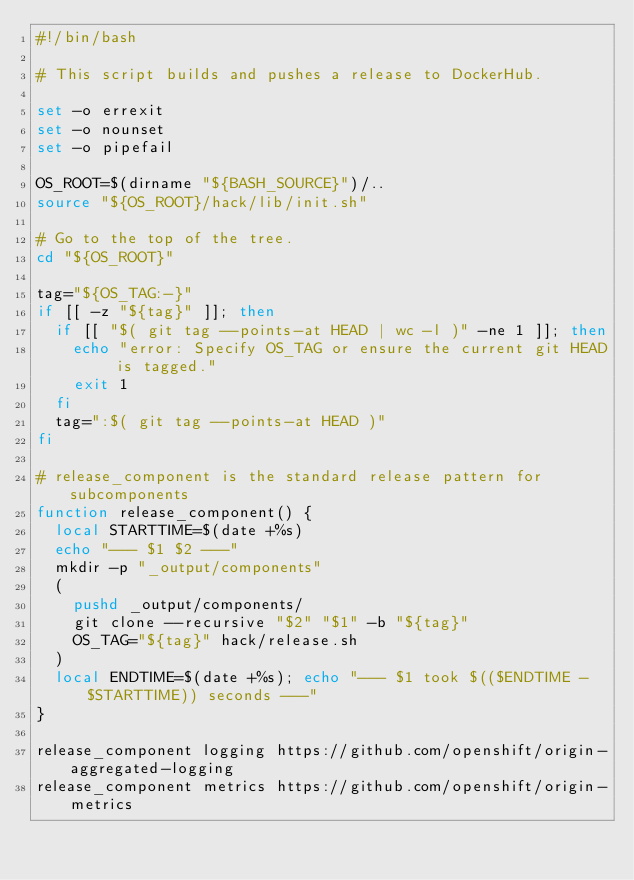<code> <loc_0><loc_0><loc_500><loc_500><_Bash_>#!/bin/bash

# This script builds and pushes a release to DockerHub.

set -o errexit
set -o nounset
set -o pipefail

OS_ROOT=$(dirname "${BASH_SOURCE}")/..
source "${OS_ROOT}/hack/lib/init.sh"

# Go to the top of the tree.
cd "${OS_ROOT}"

tag="${OS_TAG:-}"
if [[ -z "${tag}" ]]; then
  if [[ "$( git tag --points-at HEAD | wc -l )" -ne 1 ]]; then
    echo "error: Specify OS_TAG or ensure the current git HEAD is tagged."
    exit 1
  fi
  tag=":$( git tag --points-at HEAD )"
fi

# release_component is the standard release pattern for subcomponents
function release_component() {
  local STARTTIME=$(date +%s)
  echo "--- $1 $2 ---"
  mkdir -p "_output/components"
  (
    pushd _output/components/
    git clone --recursive "$2" "$1" -b "${tag}"
    OS_TAG="${tag}" hack/release.sh
  )
  local ENDTIME=$(date +%s); echo "--- $1 took $(($ENDTIME - $STARTTIME)) seconds ---"
}

release_component logging https://github.com/openshift/origin-aggregated-logging
release_component metrics https://github.com/openshift/origin-metrics</code> 